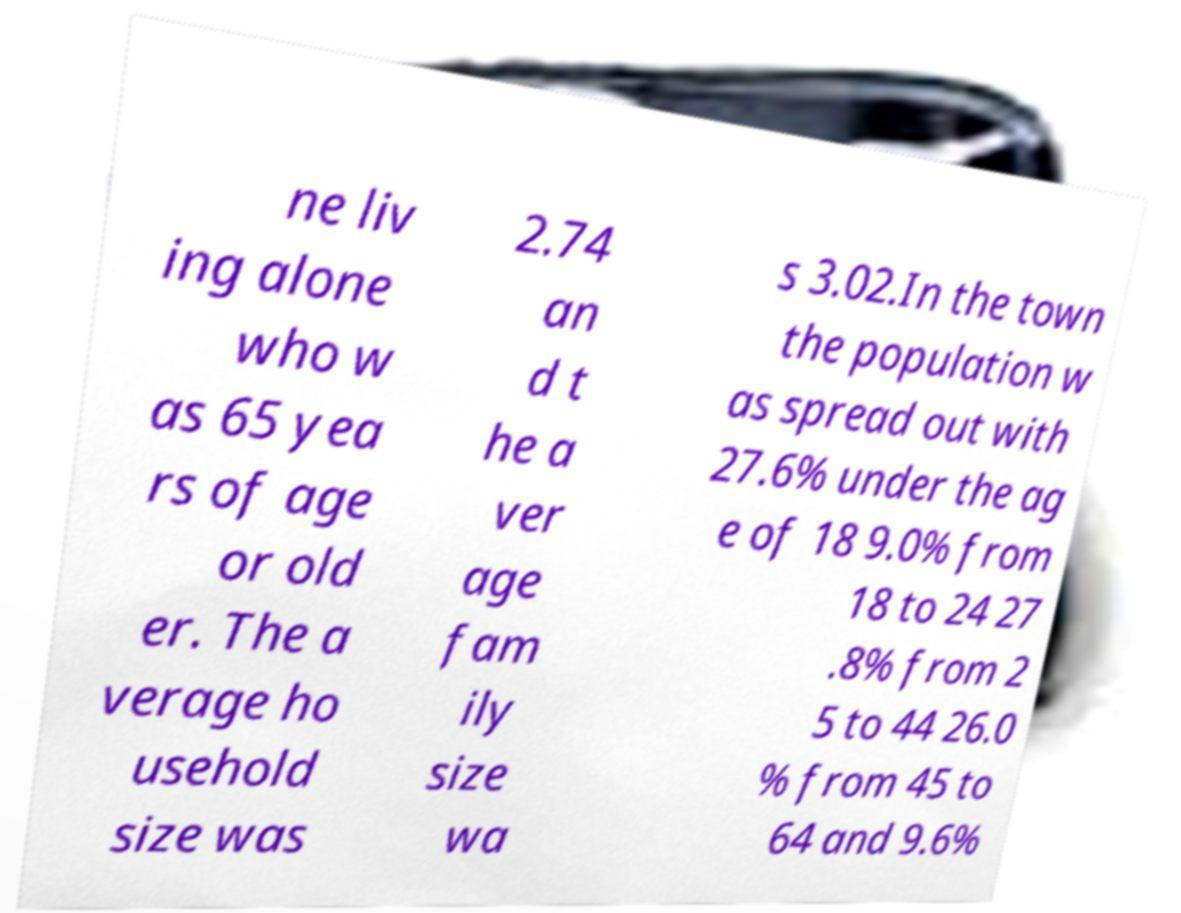Please identify and transcribe the text found in this image. ne liv ing alone who w as 65 yea rs of age or old er. The a verage ho usehold size was 2.74 an d t he a ver age fam ily size wa s 3.02.In the town the population w as spread out with 27.6% under the ag e of 18 9.0% from 18 to 24 27 .8% from 2 5 to 44 26.0 % from 45 to 64 and 9.6% 